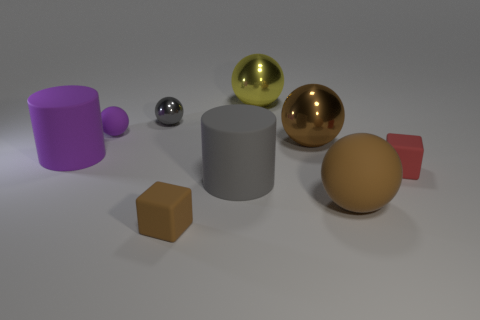How many blue metallic objects are the same shape as the small gray shiny object? 0 